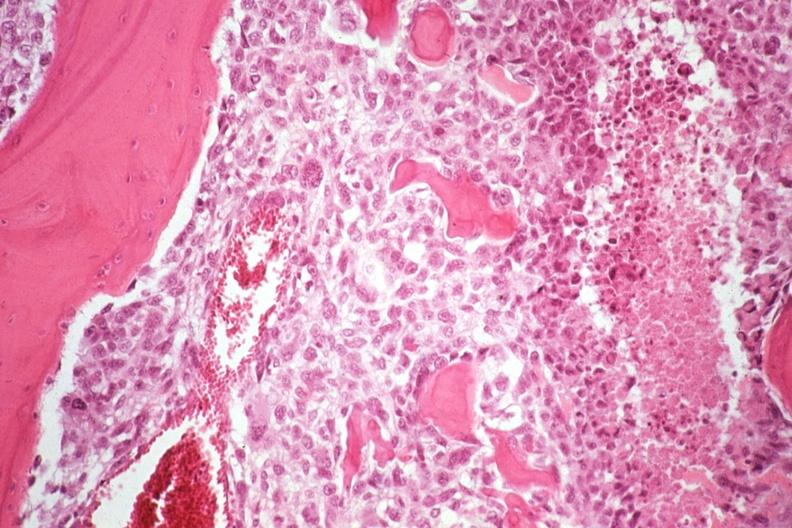what does this image show?
Answer the question using a single word or phrase. Neoplastic osteoblasts and tumor osteoid 